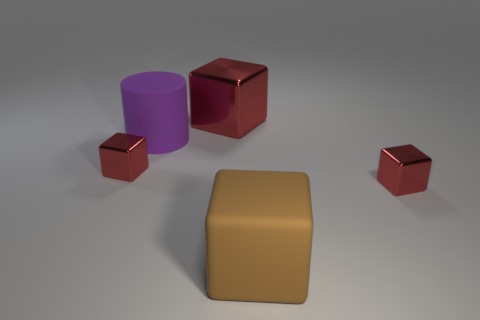What is the material of the red thing that is behind the big purple object?
Your response must be concise. Metal. Is there a gray shiny cube that has the same size as the purple cylinder?
Offer a terse response. No. There is a large block that is behind the big purple cylinder; does it have the same color as the large matte cylinder?
Ensure brevity in your answer.  No. How many gray objects are either cylinders or cubes?
Make the answer very short. 0. What number of metal blocks have the same color as the big metal thing?
Keep it short and to the point. 2. Is the big brown block made of the same material as the big red block?
Make the answer very short. No. What number of small red cubes are on the right side of the tiny block to the left of the large metallic cube?
Offer a very short reply. 1. How many brown things have the same material as the big brown cube?
Make the answer very short. 0. There is another matte object that is the same shape as the large red thing; what size is it?
Provide a succinct answer. Large. Do the small object on the right side of the brown rubber object and the purple thing have the same shape?
Provide a succinct answer. No. 